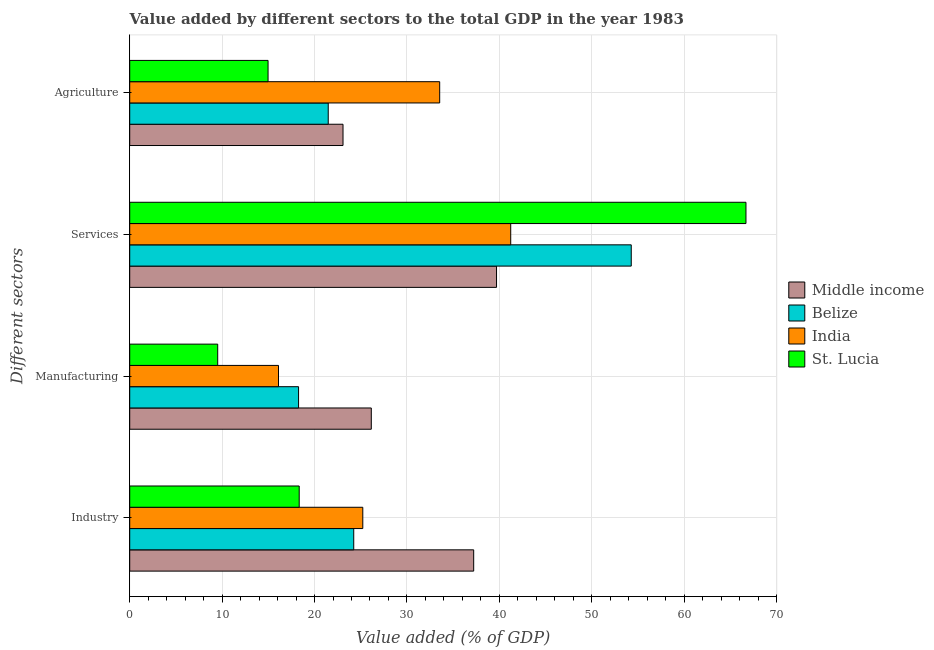How many different coloured bars are there?
Make the answer very short. 4. How many groups of bars are there?
Provide a short and direct response. 4. Are the number of bars per tick equal to the number of legend labels?
Provide a succinct answer. Yes. What is the label of the 4th group of bars from the top?
Your answer should be very brief. Industry. What is the value added by manufacturing sector in India?
Offer a terse response. 16.1. Across all countries, what is the maximum value added by manufacturing sector?
Provide a short and direct response. 26.14. Across all countries, what is the minimum value added by manufacturing sector?
Ensure brevity in your answer.  9.52. In which country was the value added by agricultural sector minimum?
Provide a succinct answer. St. Lucia. What is the total value added by manufacturing sector in the graph?
Ensure brevity in your answer.  70.04. What is the difference between the value added by industrial sector in Middle income and that in St. Lucia?
Your response must be concise. 18.88. What is the difference between the value added by industrial sector in Belize and the value added by manufacturing sector in St. Lucia?
Your answer should be compact. 14.72. What is the average value added by services sector per country?
Make the answer very short. 50.47. What is the difference between the value added by industrial sector and value added by agricultural sector in Belize?
Offer a terse response. 2.76. What is the ratio of the value added by industrial sector in India to that in Middle income?
Offer a terse response. 0.68. What is the difference between the highest and the second highest value added by manufacturing sector?
Ensure brevity in your answer.  7.87. What is the difference between the highest and the lowest value added by agricultural sector?
Give a very brief answer. 18.57. Is the sum of the value added by industrial sector in India and Middle income greater than the maximum value added by manufacturing sector across all countries?
Provide a succinct answer. Yes. Is it the case that in every country, the sum of the value added by services sector and value added by industrial sector is greater than the sum of value added by agricultural sector and value added by manufacturing sector?
Your answer should be very brief. Yes. Is it the case that in every country, the sum of the value added by industrial sector and value added by manufacturing sector is greater than the value added by services sector?
Make the answer very short. No. How many bars are there?
Give a very brief answer. 16. Are all the bars in the graph horizontal?
Your answer should be very brief. Yes. What is the difference between two consecutive major ticks on the X-axis?
Make the answer very short. 10. Does the graph contain grids?
Provide a short and direct response. Yes. Where does the legend appear in the graph?
Offer a very short reply. Center right. How many legend labels are there?
Ensure brevity in your answer.  4. How are the legend labels stacked?
Give a very brief answer. Vertical. What is the title of the graph?
Keep it short and to the point. Value added by different sectors to the total GDP in the year 1983. Does "Jordan" appear as one of the legend labels in the graph?
Provide a short and direct response. No. What is the label or title of the X-axis?
Offer a very short reply. Value added (% of GDP). What is the label or title of the Y-axis?
Provide a short and direct response. Different sectors. What is the Value added (% of GDP) of Middle income in Industry?
Provide a succinct answer. 37.22. What is the Value added (% of GDP) of Belize in Industry?
Provide a succinct answer. 24.24. What is the Value added (% of GDP) of India in Industry?
Offer a very short reply. 25.22. What is the Value added (% of GDP) in St. Lucia in Industry?
Ensure brevity in your answer.  18.34. What is the Value added (% of GDP) in Middle income in Manufacturing?
Provide a succinct answer. 26.14. What is the Value added (% of GDP) in Belize in Manufacturing?
Provide a short and direct response. 18.27. What is the Value added (% of GDP) of India in Manufacturing?
Make the answer very short. 16.1. What is the Value added (% of GDP) of St. Lucia in Manufacturing?
Your response must be concise. 9.52. What is the Value added (% of GDP) in Middle income in Services?
Your answer should be very brief. 39.7. What is the Value added (% of GDP) of Belize in Services?
Provide a short and direct response. 54.28. What is the Value added (% of GDP) of India in Services?
Your response must be concise. 41.23. What is the Value added (% of GDP) in St. Lucia in Services?
Your answer should be very brief. 66.69. What is the Value added (% of GDP) of Middle income in Agriculture?
Offer a terse response. 23.08. What is the Value added (% of GDP) of Belize in Agriculture?
Offer a very short reply. 21.48. What is the Value added (% of GDP) of India in Agriculture?
Give a very brief answer. 33.54. What is the Value added (% of GDP) of St. Lucia in Agriculture?
Offer a terse response. 14.97. Across all Different sectors, what is the maximum Value added (% of GDP) of Middle income?
Provide a succinct answer. 39.7. Across all Different sectors, what is the maximum Value added (% of GDP) of Belize?
Your answer should be compact. 54.28. Across all Different sectors, what is the maximum Value added (% of GDP) of India?
Your response must be concise. 41.23. Across all Different sectors, what is the maximum Value added (% of GDP) in St. Lucia?
Give a very brief answer. 66.69. Across all Different sectors, what is the minimum Value added (% of GDP) of Middle income?
Offer a terse response. 23.08. Across all Different sectors, what is the minimum Value added (% of GDP) of Belize?
Your answer should be compact. 18.27. Across all Different sectors, what is the minimum Value added (% of GDP) of India?
Offer a terse response. 16.1. Across all Different sectors, what is the minimum Value added (% of GDP) in St. Lucia?
Offer a terse response. 9.52. What is the total Value added (% of GDP) in Middle income in the graph?
Make the answer very short. 126.14. What is the total Value added (% of GDP) of Belize in the graph?
Your response must be concise. 118.27. What is the total Value added (% of GDP) of India in the graph?
Your answer should be compact. 116.1. What is the total Value added (% of GDP) in St. Lucia in the graph?
Your answer should be compact. 109.52. What is the difference between the Value added (% of GDP) of Middle income in Industry and that in Manufacturing?
Keep it short and to the point. 11.08. What is the difference between the Value added (% of GDP) in Belize in Industry and that in Manufacturing?
Offer a terse response. 5.97. What is the difference between the Value added (% of GDP) in India in Industry and that in Manufacturing?
Your answer should be very brief. 9.12. What is the difference between the Value added (% of GDP) of St. Lucia in Industry and that in Manufacturing?
Your answer should be compact. 8.82. What is the difference between the Value added (% of GDP) in Middle income in Industry and that in Services?
Provide a succinct answer. -2.47. What is the difference between the Value added (% of GDP) in Belize in Industry and that in Services?
Provide a succinct answer. -30.03. What is the difference between the Value added (% of GDP) in India in Industry and that in Services?
Ensure brevity in your answer.  -16.01. What is the difference between the Value added (% of GDP) of St. Lucia in Industry and that in Services?
Keep it short and to the point. -48.35. What is the difference between the Value added (% of GDP) in Middle income in Industry and that in Agriculture?
Ensure brevity in your answer.  14.14. What is the difference between the Value added (% of GDP) in Belize in Industry and that in Agriculture?
Offer a terse response. 2.76. What is the difference between the Value added (% of GDP) of India in Industry and that in Agriculture?
Your answer should be very brief. -8.32. What is the difference between the Value added (% of GDP) in St. Lucia in Industry and that in Agriculture?
Ensure brevity in your answer.  3.37. What is the difference between the Value added (% of GDP) in Middle income in Manufacturing and that in Services?
Ensure brevity in your answer.  -13.55. What is the difference between the Value added (% of GDP) of Belize in Manufacturing and that in Services?
Make the answer very short. -36. What is the difference between the Value added (% of GDP) in India in Manufacturing and that in Services?
Make the answer very short. -25.13. What is the difference between the Value added (% of GDP) of St. Lucia in Manufacturing and that in Services?
Your answer should be very brief. -57.17. What is the difference between the Value added (% of GDP) in Middle income in Manufacturing and that in Agriculture?
Keep it short and to the point. 3.06. What is the difference between the Value added (% of GDP) in Belize in Manufacturing and that in Agriculture?
Offer a terse response. -3.21. What is the difference between the Value added (% of GDP) in India in Manufacturing and that in Agriculture?
Ensure brevity in your answer.  -17.44. What is the difference between the Value added (% of GDP) in St. Lucia in Manufacturing and that in Agriculture?
Your answer should be very brief. -5.45. What is the difference between the Value added (% of GDP) in Middle income in Services and that in Agriculture?
Your answer should be very brief. 16.61. What is the difference between the Value added (% of GDP) in Belize in Services and that in Agriculture?
Offer a very short reply. 32.79. What is the difference between the Value added (% of GDP) of India in Services and that in Agriculture?
Keep it short and to the point. 7.69. What is the difference between the Value added (% of GDP) of St. Lucia in Services and that in Agriculture?
Offer a terse response. 51.72. What is the difference between the Value added (% of GDP) in Middle income in Industry and the Value added (% of GDP) in Belize in Manufacturing?
Give a very brief answer. 18.95. What is the difference between the Value added (% of GDP) of Middle income in Industry and the Value added (% of GDP) of India in Manufacturing?
Provide a succinct answer. 21.12. What is the difference between the Value added (% of GDP) in Middle income in Industry and the Value added (% of GDP) in St. Lucia in Manufacturing?
Your answer should be very brief. 27.7. What is the difference between the Value added (% of GDP) of Belize in Industry and the Value added (% of GDP) of India in Manufacturing?
Provide a short and direct response. 8.14. What is the difference between the Value added (% of GDP) in Belize in Industry and the Value added (% of GDP) in St. Lucia in Manufacturing?
Provide a short and direct response. 14.72. What is the difference between the Value added (% of GDP) of India in Industry and the Value added (% of GDP) of St. Lucia in Manufacturing?
Ensure brevity in your answer.  15.7. What is the difference between the Value added (% of GDP) of Middle income in Industry and the Value added (% of GDP) of Belize in Services?
Your answer should be compact. -17.05. What is the difference between the Value added (% of GDP) of Middle income in Industry and the Value added (% of GDP) of India in Services?
Ensure brevity in your answer.  -4.01. What is the difference between the Value added (% of GDP) of Middle income in Industry and the Value added (% of GDP) of St. Lucia in Services?
Offer a very short reply. -29.47. What is the difference between the Value added (% of GDP) of Belize in Industry and the Value added (% of GDP) of India in Services?
Provide a succinct answer. -16.99. What is the difference between the Value added (% of GDP) in Belize in Industry and the Value added (% of GDP) in St. Lucia in Services?
Give a very brief answer. -42.45. What is the difference between the Value added (% of GDP) in India in Industry and the Value added (% of GDP) in St. Lucia in Services?
Offer a very short reply. -41.47. What is the difference between the Value added (% of GDP) of Middle income in Industry and the Value added (% of GDP) of Belize in Agriculture?
Provide a succinct answer. 15.74. What is the difference between the Value added (% of GDP) of Middle income in Industry and the Value added (% of GDP) of India in Agriculture?
Provide a short and direct response. 3.68. What is the difference between the Value added (% of GDP) in Middle income in Industry and the Value added (% of GDP) in St. Lucia in Agriculture?
Keep it short and to the point. 22.25. What is the difference between the Value added (% of GDP) of Belize in Industry and the Value added (% of GDP) of India in Agriculture?
Give a very brief answer. -9.3. What is the difference between the Value added (% of GDP) of Belize in Industry and the Value added (% of GDP) of St. Lucia in Agriculture?
Ensure brevity in your answer.  9.27. What is the difference between the Value added (% of GDP) of India in Industry and the Value added (% of GDP) of St. Lucia in Agriculture?
Give a very brief answer. 10.25. What is the difference between the Value added (% of GDP) in Middle income in Manufacturing and the Value added (% of GDP) in Belize in Services?
Your response must be concise. -28.13. What is the difference between the Value added (% of GDP) in Middle income in Manufacturing and the Value added (% of GDP) in India in Services?
Provide a succinct answer. -15.09. What is the difference between the Value added (% of GDP) of Middle income in Manufacturing and the Value added (% of GDP) of St. Lucia in Services?
Make the answer very short. -40.55. What is the difference between the Value added (% of GDP) of Belize in Manufacturing and the Value added (% of GDP) of India in Services?
Provide a short and direct response. -22.96. What is the difference between the Value added (% of GDP) in Belize in Manufacturing and the Value added (% of GDP) in St. Lucia in Services?
Keep it short and to the point. -48.42. What is the difference between the Value added (% of GDP) in India in Manufacturing and the Value added (% of GDP) in St. Lucia in Services?
Your response must be concise. -50.59. What is the difference between the Value added (% of GDP) of Middle income in Manufacturing and the Value added (% of GDP) of Belize in Agriculture?
Give a very brief answer. 4.66. What is the difference between the Value added (% of GDP) in Middle income in Manufacturing and the Value added (% of GDP) in India in Agriculture?
Provide a succinct answer. -7.4. What is the difference between the Value added (% of GDP) of Middle income in Manufacturing and the Value added (% of GDP) of St. Lucia in Agriculture?
Your answer should be very brief. 11.17. What is the difference between the Value added (% of GDP) of Belize in Manufacturing and the Value added (% of GDP) of India in Agriculture?
Give a very brief answer. -15.27. What is the difference between the Value added (% of GDP) in Belize in Manufacturing and the Value added (% of GDP) in St. Lucia in Agriculture?
Offer a terse response. 3.3. What is the difference between the Value added (% of GDP) of India in Manufacturing and the Value added (% of GDP) of St. Lucia in Agriculture?
Offer a terse response. 1.13. What is the difference between the Value added (% of GDP) in Middle income in Services and the Value added (% of GDP) in Belize in Agriculture?
Provide a succinct answer. 18.21. What is the difference between the Value added (% of GDP) in Middle income in Services and the Value added (% of GDP) in India in Agriculture?
Make the answer very short. 6.15. What is the difference between the Value added (% of GDP) in Middle income in Services and the Value added (% of GDP) in St. Lucia in Agriculture?
Give a very brief answer. 24.73. What is the difference between the Value added (% of GDP) in Belize in Services and the Value added (% of GDP) in India in Agriculture?
Your answer should be very brief. 20.73. What is the difference between the Value added (% of GDP) in Belize in Services and the Value added (% of GDP) in St. Lucia in Agriculture?
Keep it short and to the point. 39.31. What is the difference between the Value added (% of GDP) of India in Services and the Value added (% of GDP) of St. Lucia in Agriculture?
Your answer should be very brief. 26.26. What is the average Value added (% of GDP) of Middle income per Different sectors?
Offer a very short reply. 31.54. What is the average Value added (% of GDP) in Belize per Different sectors?
Provide a short and direct response. 29.57. What is the average Value added (% of GDP) in India per Different sectors?
Make the answer very short. 29.03. What is the average Value added (% of GDP) in St. Lucia per Different sectors?
Keep it short and to the point. 27.38. What is the difference between the Value added (% of GDP) of Middle income and Value added (% of GDP) of Belize in Industry?
Ensure brevity in your answer.  12.98. What is the difference between the Value added (% of GDP) of Middle income and Value added (% of GDP) of India in Industry?
Provide a succinct answer. 12. What is the difference between the Value added (% of GDP) of Middle income and Value added (% of GDP) of St. Lucia in Industry?
Offer a very short reply. 18.88. What is the difference between the Value added (% of GDP) in Belize and Value added (% of GDP) in India in Industry?
Your answer should be very brief. -0.98. What is the difference between the Value added (% of GDP) in Belize and Value added (% of GDP) in St. Lucia in Industry?
Offer a very short reply. 5.9. What is the difference between the Value added (% of GDP) of India and Value added (% of GDP) of St. Lucia in Industry?
Make the answer very short. 6.88. What is the difference between the Value added (% of GDP) in Middle income and Value added (% of GDP) in Belize in Manufacturing?
Your answer should be very brief. 7.87. What is the difference between the Value added (% of GDP) of Middle income and Value added (% of GDP) of India in Manufacturing?
Keep it short and to the point. 10.04. What is the difference between the Value added (% of GDP) in Middle income and Value added (% of GDP) in St. Lucia in Manufacturing?
Your response must be concise. 16.62. What is the difference between the Value added (% of GDP) in Belize and Value added (% of GDP) in India in Manufacturing?
Provide a succinct answer. 2.17. What is the difference between the Value added (% of GDP) in Belize and Value added (% of GDP) in St. Lucia in Manufacturing?
Keep it short and to the point. 8.75. What is the difference between the Value added (% of GDP) of India and Value added (% of GDP) of St. Lucia in Manufacturing?
Your response must be concise. 6.58. What is the difference between the Value added (% of GDP) in Middle income and Value added (% of GDP) in Belize in Services?
Give a very brief answer. -14.58. What is the difference between the Value added (% of GDP) in Middle income and Value added (% of GDP) in India in Services?
Your answer should be very brief. -1.54. What is the difference between the Value added (% of GDP) in Middle income and Value added (% of GDP) in St. Lucia in Services?
Offer a very short reply. -26.99. What is the difference between the Value added (% of GDP) in Belize and Value added (% of GDP) in India in Services?
Keep it short and to the point. 13.04. What is the difference between the Value added (% of GDP) in Belize and Value added (% of GDP) in St. Lucia in Services?
Your answer should be compact. -12.41. What is the difference between the Value added (% of GDP) in India and Value added (% of GDP) in St. Lucia in Services?
Keep it short and to the point. -25.46. What is the difference between the Value added (% of GDP) in Middle income and Value added (% of GDP) in Belize in Agriculture?
Your answer should be very brief. 1.6. What is the difference between the Value added (% of GDP) in Middle income and Value added (% of GDP) in India in Agriculture?
Ensure brevity in your answer.  -10.46. What is the difference between the Value added (% of GDP) of Middle income and Value added (% of GDP) of St. Lucia in Agriculture?
Give a very brief answer. 8.11. What is the difference between the Value added (% of GDP) of Belize and Value added (% of GDP) of India in Agriculture?
Give a very brief answer. -12.06. What is the difference between the Value added (% of GDP) in Belize and Value added (% of GDP) in St. Lucia in Agriculture?
Make the answer very short. 6.51. What is the difference between the Value added (% of GDP) of India and Value added (% of GDP) of St. Lucia in Agriculture?
Ensure brevity in your answer.  18.57. What is the ratio of the Value added (% of GDP) in Middle income in Industry to that in Manufacturing?
Provide a short and direct response. 1.42. What is the ratio of the Value added (% of GDP) of Belize in Industry to that in Manufacturing?
Your answer should be compact. 1.33. What is the ratio of the Value added (% of GDP) of India in Industry to that in Manufacturing?
Provide a succinct answer. 1.57. What is the ratio of the Value added (% of GDP) of St. Lucia in Industry to that in Manufacturing?
Keep it short and to the point. 1.93. What is the ratio of the Value added (% of GDP) of Middle income in Industry to that in Services?
Give a very brief answer. 0.94. What is the ratio of the Value added (% of GDP) of Belize in Industry to that in Services?
Make the answer very short. 0.45. What is the ratio of the Value added (% of GDP) of India in Industry to that in Services?
Your response must be concise. 0.61. What is the ratio of the Value added (% of GDP) in St. Lucia in Industry to that in Services?
Keep it short and to the point. 0.28. What is the ratio of the Value added (% of GDP) in Middle income in Industry to that in Agriculture?
Your answer should be very brief. 1.61. What is the ratio of the Value added (% of GDP) of Belize in Industry to that in Agriculture?
Your answer should be very brief. 1.13. What is the ratio of the Value added (% of GDP) in India in Industry to that in Agriculture?
Provide a succinct answer. 0.75. What is the ratio of the Value added (% of GDP) of St. Lucia in Industry to that in Agriculture?
Provide a succinct answer. 1.23. What is the ratio of the Value added (% of GDP) of Middle income in Manufacturing to that in Services?
Your response must be concise. 0.66. What is the ratio of the Value added (% of GDP) in Belize in Manufacturing to that in Services?
Your answer should be very brief. 0.34. What is the ratio of the Value added (% of GDP) of India in Manufacturing to that in Services?
Offer a very short reply. 0.39. What is the ratio of the Value added (% of GDP) in St. Lucia in Manufacturing to that in Services?
Provide a succinct answer. 0.14. What is the ratio of the Value added (% of GDP) of Middle income in Manufacturing to that in Agriculture?
Your answer should be compact. 1.13. What is the ratio of the Value added (% of GDP) in Belize in Manufacturing to that in Agriculture?
Your answer should be compact. 0.85. What is the ratio of the Value added (% of GDP) of India in Manufacturing to that in Agriculture?
Make the answer very short. 0.48. What is the ratio of the Value added (% of GDP) of St. Lucia in Manufacturing to that in Agriculture?
Your response must be concise. 0.64. What is the ratio of the Value added (% of GDP) in Middle income in Services to that in Agriculture?
Your answer should be very brief. 1.72. What is the ratio of the Value added (% of GDP) in Belize in Services to that in Agriculture?
Offer a very short reply. 2.53. What is the ratio of the Value added (% of GDP) in India in Services to that in Agriculture?
Offer a very short reply. 1.23. What is the ratio of the Value added (% of GDP) in St. Lucia in Services to that in Agriculture?
Your answer should be very brief. 4.45. What is the difference between the highest and the second highest Value added (% of GDP) of Middle income?
Provide a succinct answer. 2.47. What is the difference between the highest and the second highest Value added (% of GDP) of Belize?
Your answer should be very brief. 30.03. What is the difference between the highest and the second highest Value added (% of GDP) in India?
Your response must be concise. 7.69. What is the difference between the highest and the second highest Value added (% of GDP) of St. Lucia?
Your response must be concise. 48.35. What is the difference between the highest and the lowest Value added (% of GDP) in Middle income?
Offer a very short reply. 16.61. What is the difference between the highest and the lowest Value added (% of GDP) in Belize?
Make the answer very short. 36. What is the difference between the highest and the lowest Value added (% of GDP) of India?
Offer a terse response. 25.13. What is the difference between the highest and the lowest Value added (% of GDP) of St. Lucia?
Provide a succinct answer. 57.17. 